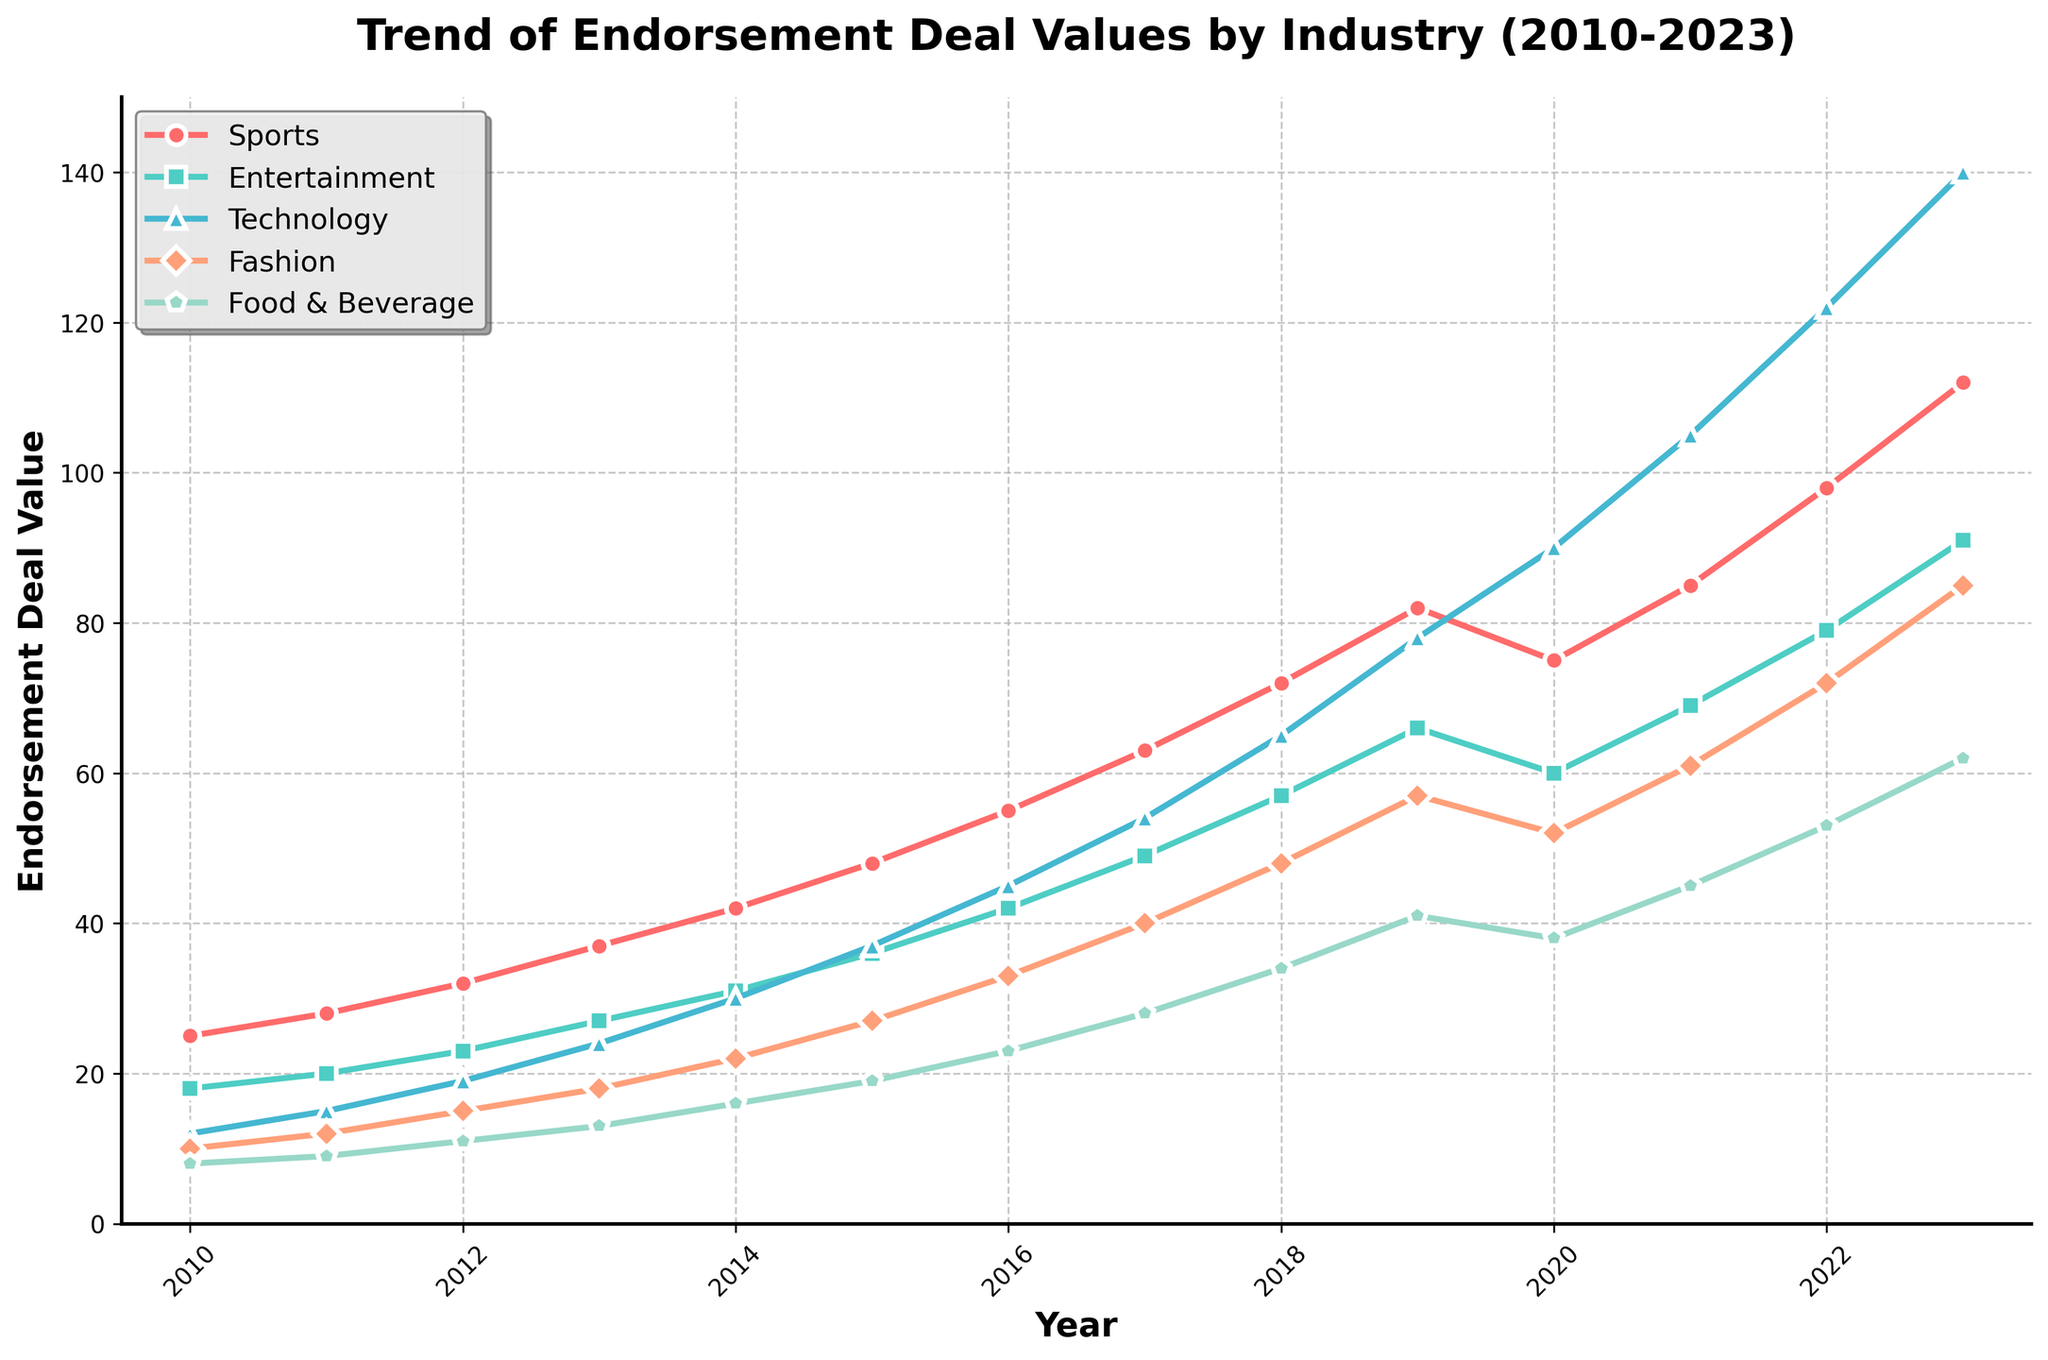What industry had the highest endorsement deal value in 2023? By observing the end points of the lines in the figure for each industry in 2023, the Technology industry has the highest value.
Answer: Technology Which two industries showed the overall highest growth from 2010 to 2023? Calculate the growth by subtracting the 2010 value from the 2023 value for each industry: Sports (112-25=87), Entertainment (91-18=73), Technology (140-12=128), Fashion (85-10=75), Food & Beverage (62-8=54). The highest growths are in Technology (128) and Sports (87).
Answer: Technology and Sports Between 2017 and 2018, which industry had the highest increase in endorsement deal value? Subtract the 2017 value from the 2018 value for each industry: Sports (72-63=9), Entertainment (57-49=8), Technology (65-54=11), Fashion (48-40=8), Food & Beverage (34-28=6). The highest increase is in Technology with 11.
Answer: Technology How does the trend of endorsement deal values for Food & Beverage compare to Fashion from 2010 to 2023? Observe the general shape and slope of the lines representing Food & Beverage and Fashion. Both are upward trends, but Fashion has a steeper slope and higher values consistently.
Answer: Fashion has a steeper trend What is the combined value of endorsement deals for Sports and Technology in 2015? Add the 2015 endorsement deal values for Sports (48) and Technology (37): 48 + 37 = 85.
Answer: 85 Which industry experienced a decline in endorsement deal value between 2019 and 2020, and by how much? Check the values in 2019 and 2020 for each industry: Sports (82 to 75), calculate the difference: 82 - 75 = 7. Only Sports experienced a decline of 7.
Answer: Sports, by 7 What's the average endorsement deal value for Fashion between 2010 and 2023? Sum up all the yearly values for Fashion and divide by the number of years: (10+12+15+18+22+27+33+40+48+57+52+61+72+85)/14 = 40.14.
Answer: 40.14 Which year saw the biggest jump in endorsement deal value for Entertainment, and by how much? Calculate yearly differences for Entertainment: 2010-2011 (20-18=2), 2011-2012 (23-20=3), ... The biggest difference is between 2021 and 2022 (79-69=10).
Answer: 2022, by 10 Rank the industries based on their endorsement deal values in 2013. Compare the 2013 values: Sports (37), Entertainment (27), Technology (24), Fashion (18), Food & Beverage (13). Arrange from highest to lowest: Sports, Entertainment, Technology, Fashion, Food & Beverage.
Answer: Sports, Entertainment, Technology, Fashion, Food & Beverage What is the proportional increase in endorsement deal values for Technology from 2010 to 2023? Calculate the initial and final values for Technology: 2010 (12), 2023 (140). Proportional increase is (140-12)/12 = 10.67.
Answer: 10.67 